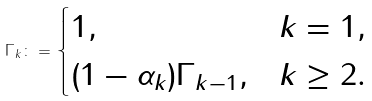<formula> <loc_0><loc_0><loc_500><loc_500>\Gamma _ { k } \colon = \begin{cases} 1 , & k = 1 , \\ ( 1 - \alpha _ { k } ) \Gamma _ { k - 1 } , & k \geq 2 . \end{cases}</formula> 